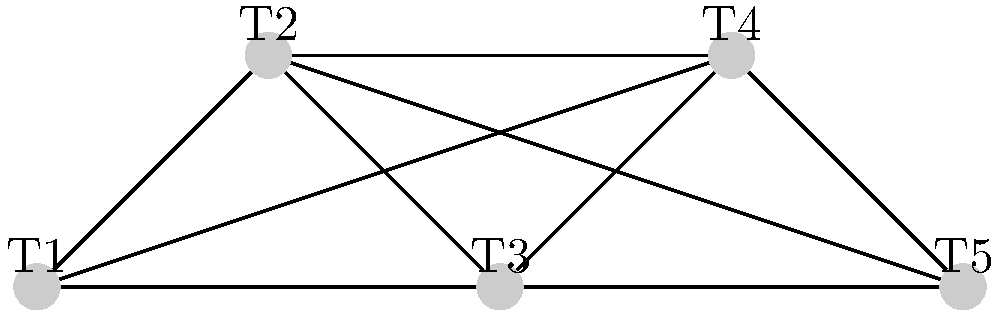As a cricket coach organizing a tournament, you need to schedule matches between 5 teams (T1, T2, T3, T4, T5) such that each team plays every other team once. The graph represents the matches to be played, where each vertex is a team and each edge is a match. Using graph coloring techniques, what is the minimum number of time slots needed to schedule all matches, ensuring no team plays more than one match in the same time slot? To solve this problem using graph coloring techniques, we follow these steps:

1. Recognize that each color in the graph represents a time slot for matches.

2. Observe that the graph is complete (every vertex is connected to every other vertex), representing that each team plays every other team once.

3. In a complete graph with $n$ vertices, the chromatic number (minimum number of colors needed) is always $n$.

4. The number of vertices in this graph is 5, representing the 5 teams.

5. Therefore, the chromatic number, and consequently the minimum number of time slots needed, is 5.

6. This solution ensures that no team plays more than one match in the same time slot, as each color (time slot) is used only once for each team.

7. The schedule could be organized as follows:
   Time Slot 1: T1 vs T2
   Time Slot 2: T1 vs T3, T2 vs T4
   Time Slot 3: T1 vs T4, T3 vs T5
   Time Slot 4: T1 vs T5, T2 vs T3
   Time Slot 5: T2 vs T5, T3 vs T4

This approach maximizes the efficiency of the tournament schedule while ensuring fair play.
Answer: 5 time slots 